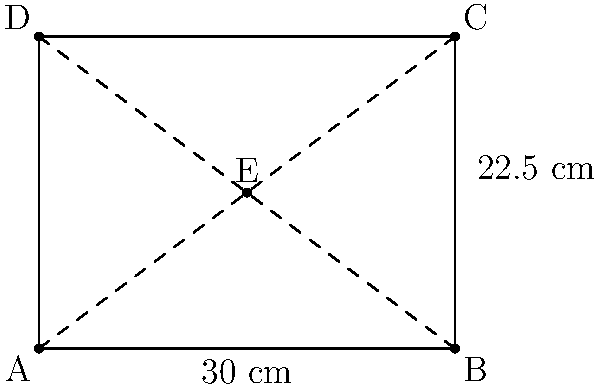A degraded wooden plank from a medieval ship has been recovered. Its current dimensions are 30 cm in length and 22.5 cm in width. Historical records suggest that the original plank was a perfect square. Assuming uniform degradation, calculate the original side length of the plank using vector scaling. Round your answer to the nearest centimeter. To solve this problem, we'll use vector scaling to determine the original dimensions of the plank:

1. Let's consider the current plank as a rectangle ABCD, with point E at its center.

2. The diagonal AC represents the vector from one corner to the opposite corner.

3. In the original square plank, this diagonal would have been equally inclined to both sides.

4. We can use the ratio of the current sides to determine the scaling factor:
   $\frac{\text{width}}{\text{length}} = \frac{22.5}{30} = 0.75$

5. This means the width has degraded more than the length. We need to scale up the width to match the length.

6. The scaling factor for the width is: $\frac{1}{0.75} = 1.333$

7. Applying this scaling factor to the width:
   $22.5 \text{ cm} \times 1.333 = 30 \text{ cm}$

8. This confirms that the original plank was indeed a square with sides of 30 cm.

Therefore, the original side length of the square plank was 30 cm.
Answer: 30 cm 